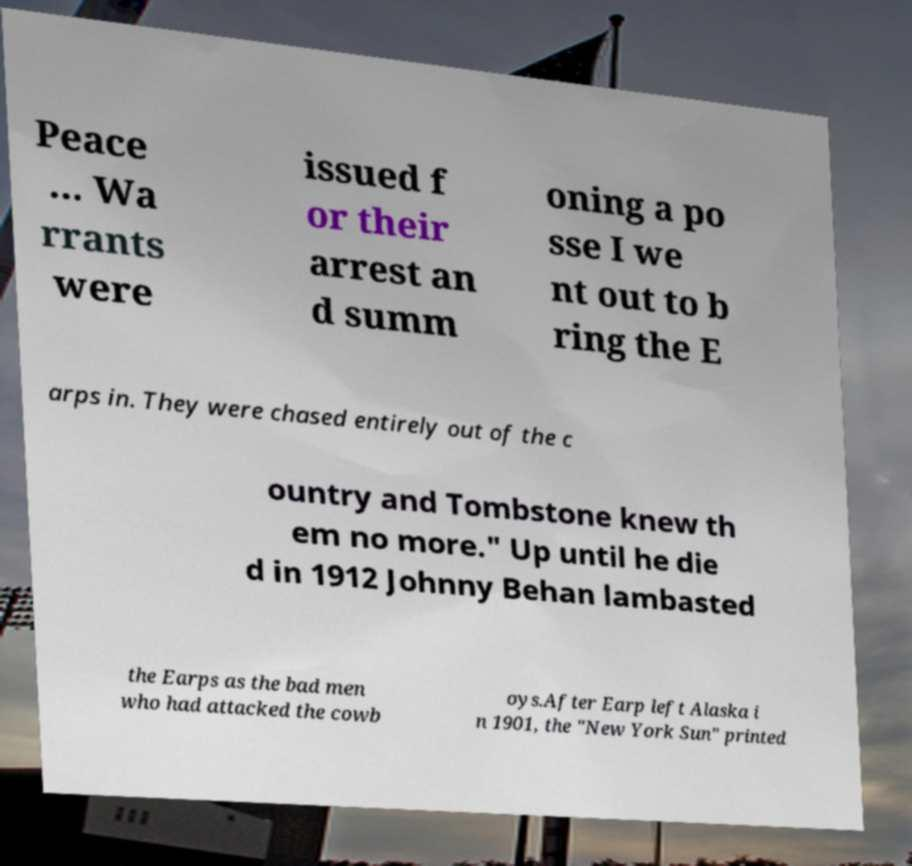What messages or text are displayed in this image? I need them in a readable, typed format. Peace ... Wa rrants were issued f or their arrest an d summ oning a po sse I we nt out to b ring the E arps in. They were chased entirely out of the c ountry and Tombstone knew th em no more." Up until he die d in 1912 Johnny Behan lambasted the Earps as the bad men who had attacked the cowb oys.After Earp left Alaska i n 1901, the "New York Sun" printed 